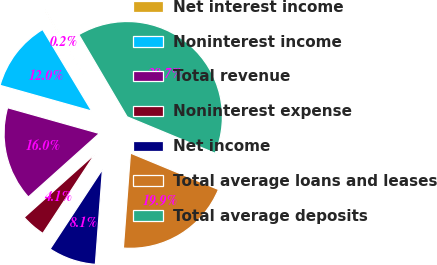Convert chart. <chart><loc_0><loc_0><loc_500><loc_500><pie_chart><fcel>Net interest income<fcel>Noninterest income<fcel>Total revenue<fcel>Noninterest expense<fcel>Net income<fcel>Total average loans and leases<fcel>Total average deposits<nl><fcel>0.16%<fcel>12.03%<fcel>15.98%<fcel>4.12%<fcel>8.07%<fcel>19.94%<fcel>39.71%<nl></chart> 